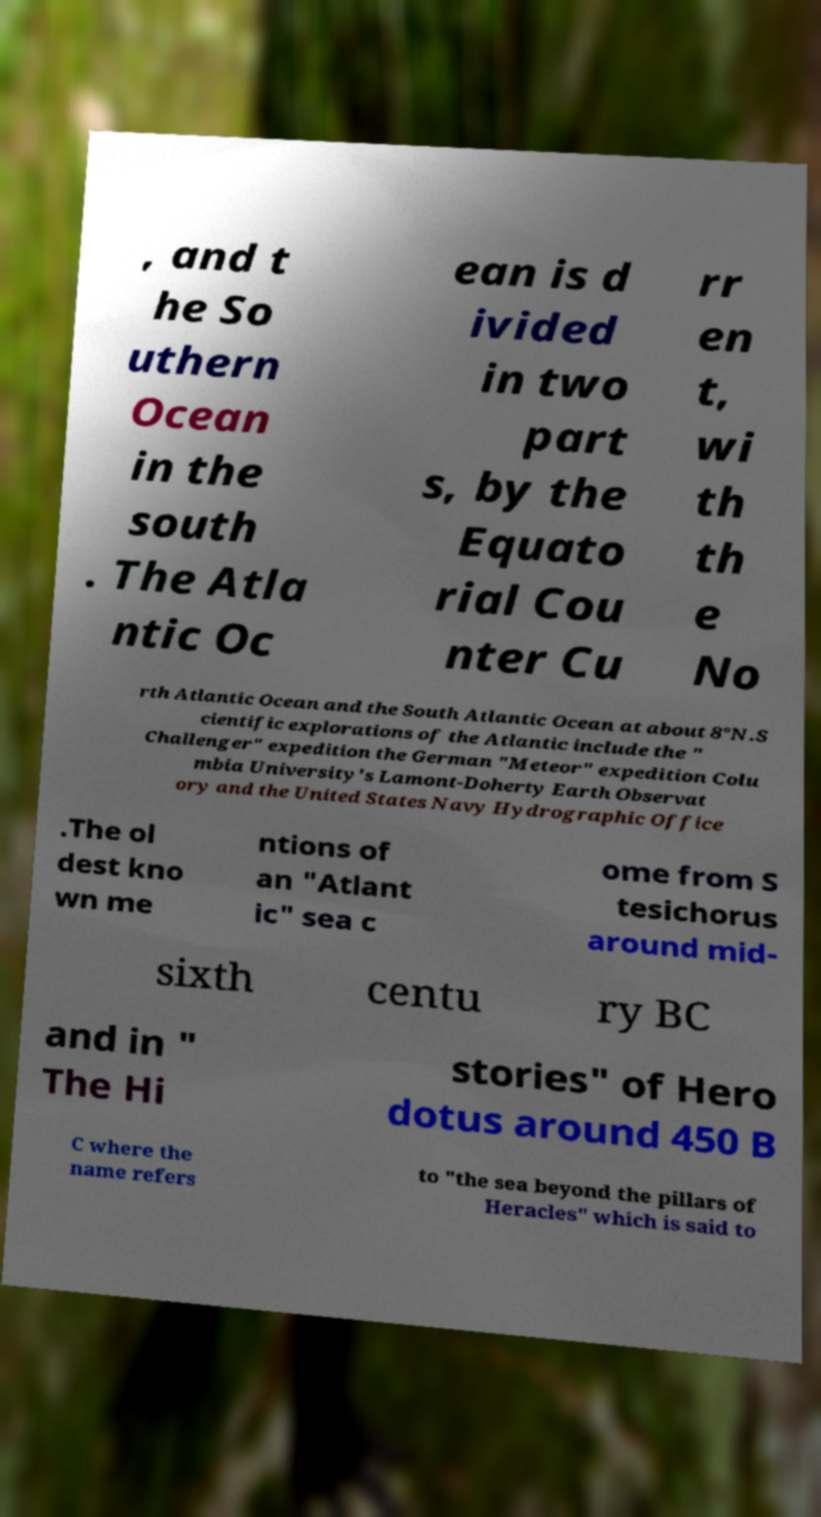Please read and relay the text visible in this image. What does it say? , and t he So uthern Ocean in the south . The Atla ntic Oc ean is d ivided in two part s, by the Equato rial Cou nter Cu rr en t, wi th th e No rth Atlantic Ocean and the South Atlantic Ocean at about 8°N.S cientific explorations of the Atlantic include the " Challenger" expedition the German "Meteor" expedition Colu mbia University's Lamont-Doherty Earth Observat ory and the United States Navy Hydrographic Office .The ol dest kno wn me ntions of an "Atlant ic" sea c ome from S tesichorus around mid- sixth centu ry BC and in " The Hi stories" of Hero dotus around 450 B C where the name refers to "the sea beyond the pillars of Heracles" which is said to 